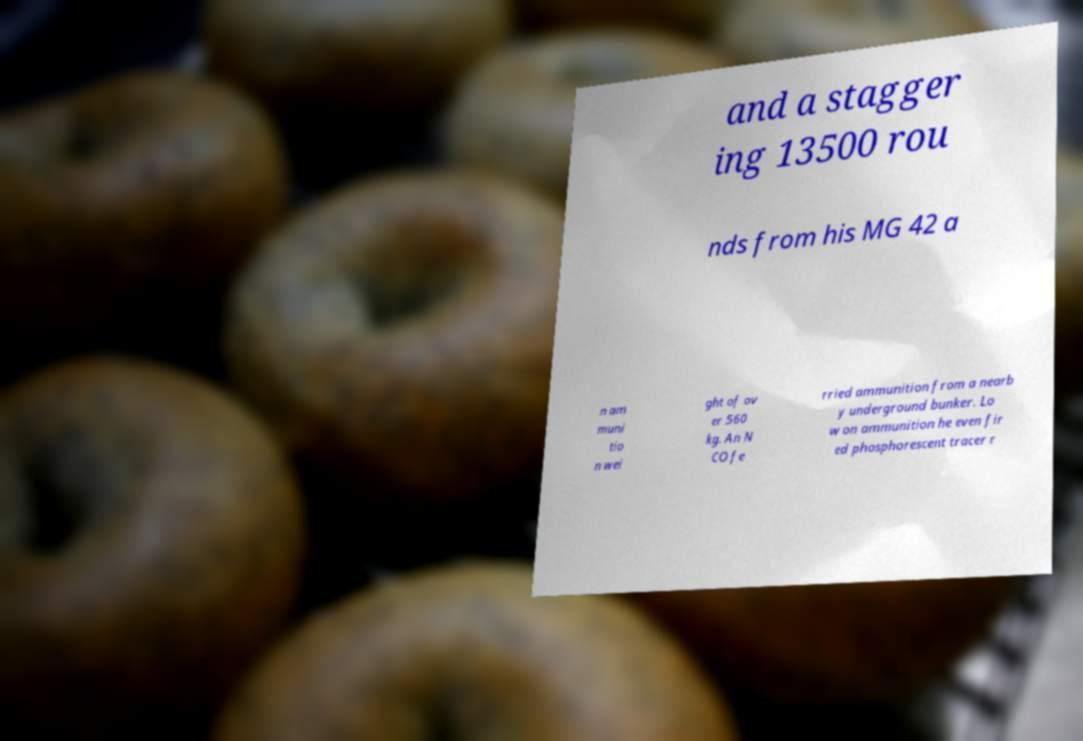I need the written content from this picture converted into text. Can you do that? and a stagger ing 13500 rou nds from his MG 42 a n am muni tio n wei ght of ov er 560 kg. An N CO fe rried ammunition from a nearb y underground bunker. Lo w on ammunition he even fir ed phosphorescent tracer r 